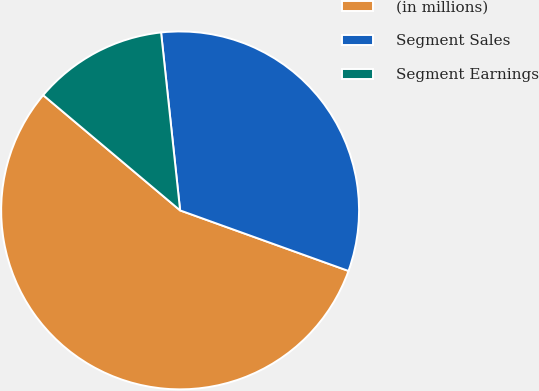Convert chart. <chart><loc_0><loc_0><loc_500><loc_500><pie_chart><fcel>(in millions)<fcel>Segment Sales<fcel>Segment Earnings<nl><fcel>55.64%<fcel>32.19%<fcel>12.17%<nl></chart> 